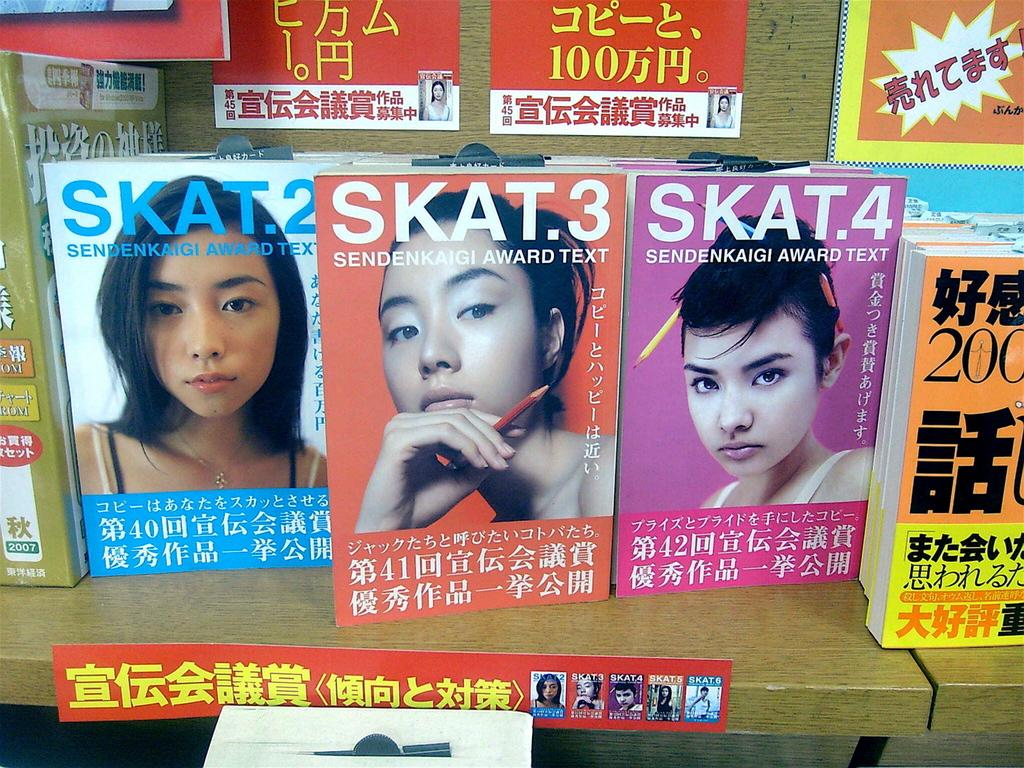What type of objects can be seen in the image? There are books and posters in the image. What are the books placed on? The books are on wooden objects. What can be found on the books? The books have images and text on them. What type of lace can be seen on the books in the image? There is no lace present on the books in the image. Can you describe the picture of the stomach on the books in the image? There is no picture of a stomach on the books in the image. 